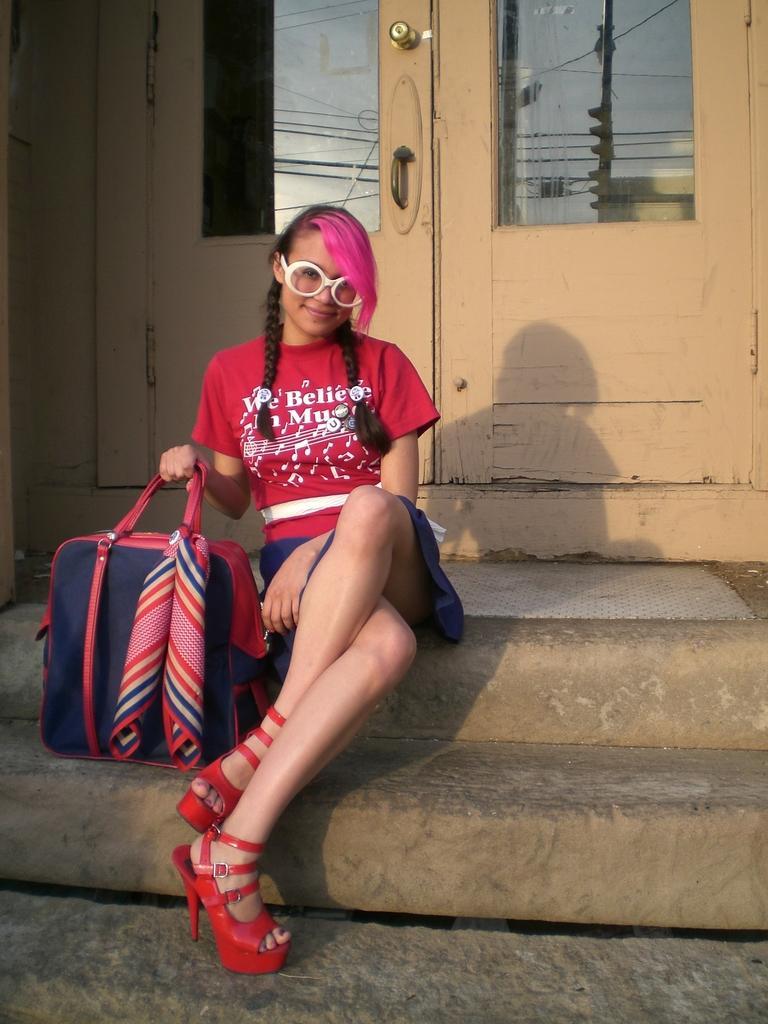Could you give a brief overview of what you see in this image? As we can see in the image there is a door and a woman sitting and holding bag. 